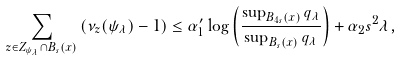<formula> <loc_0><loc_0><loc_500><loc_500>\sum _ { z \in Z _ { \psi _ { \lambda } } \cap B _ { s } ( x ) } \left ( \nu _ { z } ( \psi _ { \lambda } ) - 1 \right ) \leq \alpha ^ { \prime } _ { 1 } \log \left ( \frac { \sup _ { B _ { 4 s } ( x ) } q _ { \lambda } } { \sup _ { B _ { s } ( x ) } q _ { \lambda } } \right ) + \alpha _ { 2 } s ^ { 2 } \lambda ,</formula> 